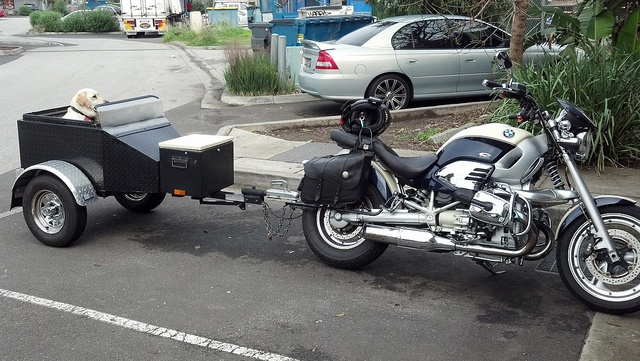Describe the objects in this image and their specific colors. I can see motorcycle in purple, black, gray, white, and darkgray tones, car in purple, gray, lightgray, darkgray, and black tones, handbag in purple, black, gray, and darkgray tones, truck in purple, white, darkgray, black, and gray tones, and dog in purple, ivory, darkgray, lightgray, and tan tones in this image. 